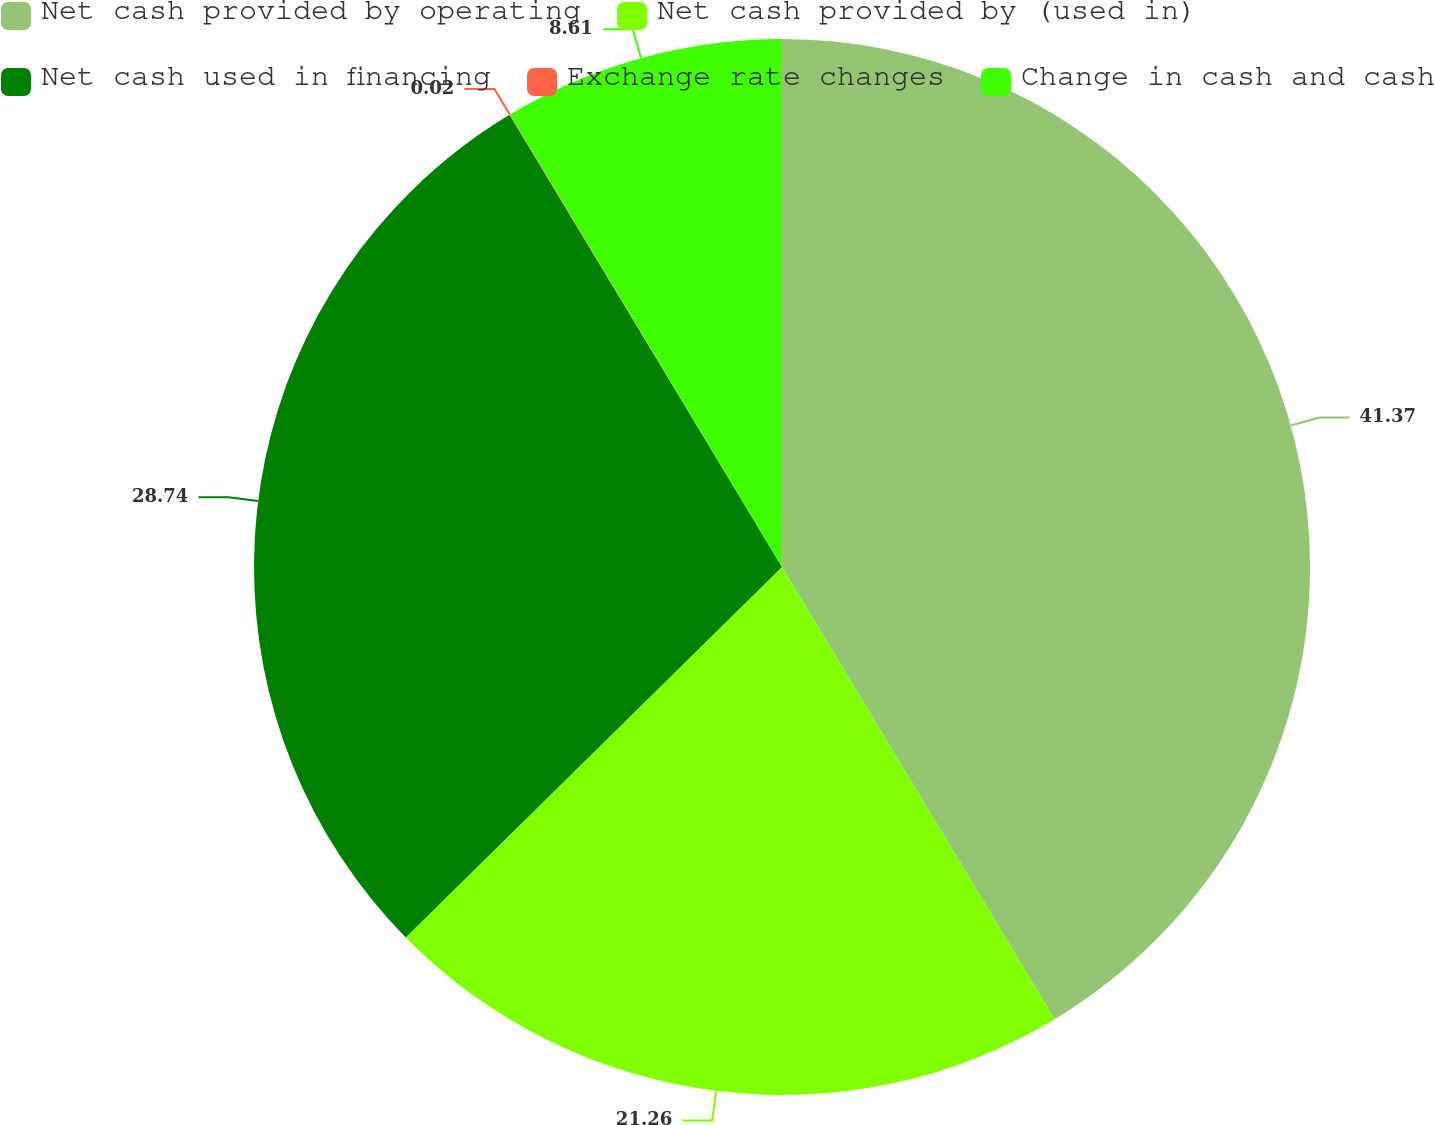Convert chart to OTSL. <chart><loc_0><loc_0><loc_500><loc_500><pie_chart><fcel>Net cash provided by operating<fcel>Net cash provided by (used in)<fcel>Net cash used in financing<fcel>Exchange rate changes<fcel>Change in cash and cash<nl><fcel>41.36%<fcel>21.26%<fcel>28.74%<fcel>0.02%<fcel>8.61%<nl></chart> 